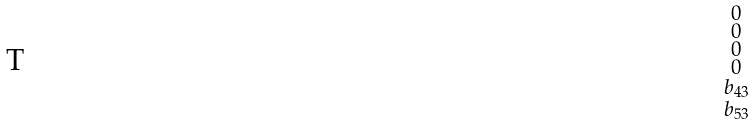<formula> <loc_0><loc_0><loc_500><loc_500>\begin{smallmatrix} 0 \\ 0 \\ 0 \\ 0 \\ b _ { 4 3 } \\ b _ { 5 3 } \\ \end{smallmatrix}</formula> 